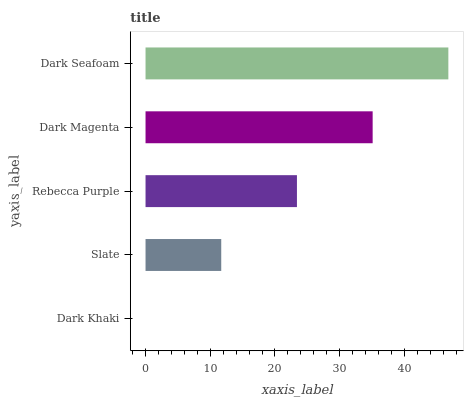Is Dark Khaki the minimum?
Answer yes or no. Yes. Is Dark Seafoam the maximum?
Answer yes or no. Yes. Is Slate the minimum?
Answer yes or no. No. Is Slate the maximum?
Answer yes or no. No. Is Slate greater than Dark Khaki?
Answer yes or no. Yes. Is Dark Khaki less than Slate?
Answer yes or no. Yes. Is Dark Khaki greater than Slate?
Answer yes or no. No. Is Slate less than Dark Khaki?
Answer yes or no. No. Is Rebecca Purple the high median?
Answer yes or no. Yes. Is Rebecca Purple the low median?
Answer yes or no. Yes. Is Dark Seafoam the high median?
Answer yes or no. No. Is Dark Khaki the low median?
Answer yes or no. No. 